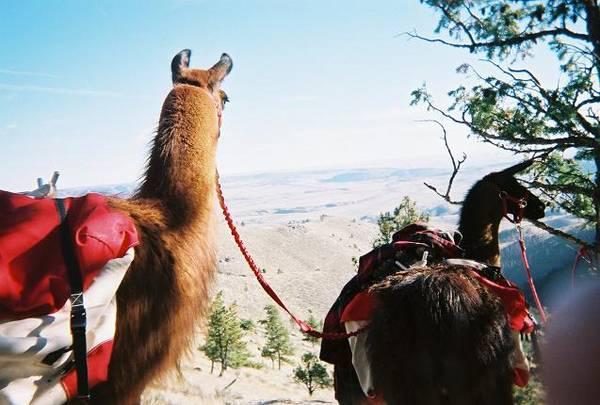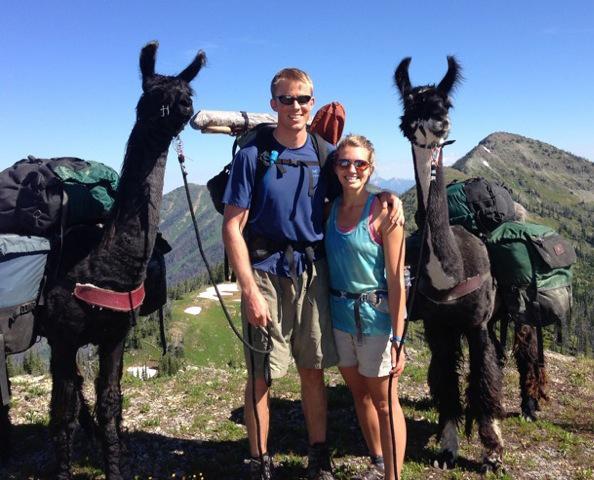The first image is the image on the left, the second image is the image on the right. Analyze the images presented: Is the assertion "Both images contain people and llamas." valid? Answer yes or no. No. The first image is the image on the left, the second image is the image on the right. For the images displayed, is the sentence "A camera-facing man and woman are standing between two pack-wearing llamas and in front of at least one peak." factually correct? Answer yes or no. Yes. 